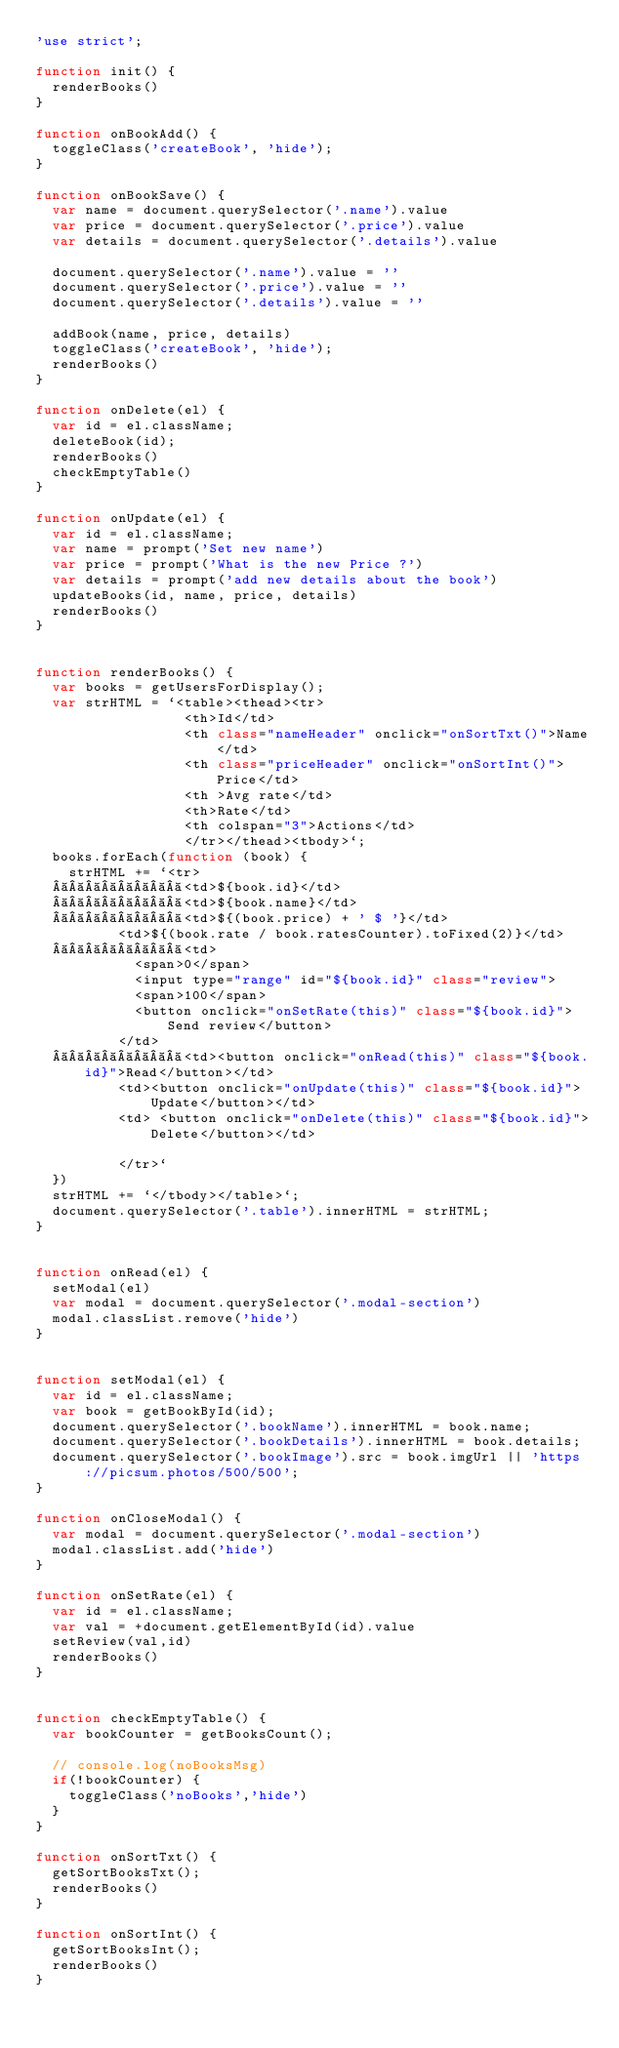Convert code to text. <code><loc_0><loc_0><loc_500><loc_500><_JavaScript_>'use strict';

function init() {
  renderBooks()
}

function onBookAdd() {
  toggleClass('createBook', 'hide');
}

function onBookSave() {
  var name = document.querySelector('.name').value
  var price = document.querySelector('.price').value
  var details = document.querySelector('.details').value

  document.querySelector('.name').value = ''
  document.querySelector('.price').value = ''
  document.querySelector('.details').value = ''

  addBook(name, price, details)
  toggleClass('createBook', 'hide');
  renderBooks()
}

function onDelete(el) {
  var id = el.className;
  deleteBook(id);
  renderBooks()
  checkEmptyTable()
}

function onUpdate(el) {
  var id = el.className;
  var name = prompt('Set new name')
  var price = prompt('What is the new Price ?')
  var details = prompt('add new details about the book')
  updateBooks(id, name, price, details)
  renderBooks()
}


function renderBooks() {
  var books = getUsersForDisplay();
  var strHTML = `<table><thead><tr>
                  <th>Id</td>
                  <th class="nameHeader" onclick="onSortTxt()">Name</td>
                  <th class="priceHeader" onclick="onSortInt()">Price</td>
                  <th >Avg rate</td>
                  <th>Rate</td>
                  <th colspan="3">Actions</td>
                  </tr></thead><tbody>`;
  books.forEach(function (book) {
    strHTML += `<tr>
          <td>${book.id}</td>
          <td>${book.name}</td>
          <td>${(book.price) + ' $ '}</td>
          <td>${(book.rate / book.ratesCounter).toFixed(2)}</td>
          <td>
            <span>0</span>
            <input type="range" id="${book.id}" class="review">
            <span>100</span>
            <button onclick="onSetRate(this)" class="${book.id}">Send review</button>
          </td>
          <td><button onclick="onRead(this)" class="${book.id}">Read</button></td>
          <td><button onclick="onUpdate(this)" class="${book.id}">Update</button></td>
          <td> <button onclick="onDelete(this)" class="${book.id}">Delete</button></td>
            
          </tr>`
  })
  strHTML += `</tbody></table>`;
  document.querySelector('.table').innerHTML = strHTML;
}


function onRead(el) {
  setModal(el)
  var modal = document.querySelector('.modal-section')
  modal.classList.remove('hide')
}


function setModal(el) {
  var id = el.className;
  var book = getBookById(id);
  document.querySelector('.bookName').innerHTML = book.name;
  document.querySelector('.bookDetails').innerHTML = book.details;
  document.querySelector('.bookImage').src = book.imgUrl || 'https://picsum.photos/500/500';
}

function onCloseModal() {
  var modal = document.querySelector('.modal-section')
  modal.classList.add('hide')
}

function onSetRate(el) {
  var id = el.className;
  var val = +document.getElementById(id).value
  setReview(val,id)
  renderBooks()
}


function checkEmptyTable() {
  var bookCounter = getBooksCount();
  
  // console.log(noBooksMsg)
  if(!bookCounter) {
    toggleClass('noBooks','hide')
  }
}

function onSortTxt() {
  getSortBooksTxt();
  renderBooks()
}

function onSortInt() {
  getSortBooksInt();
  renderBooks()
} </code> 